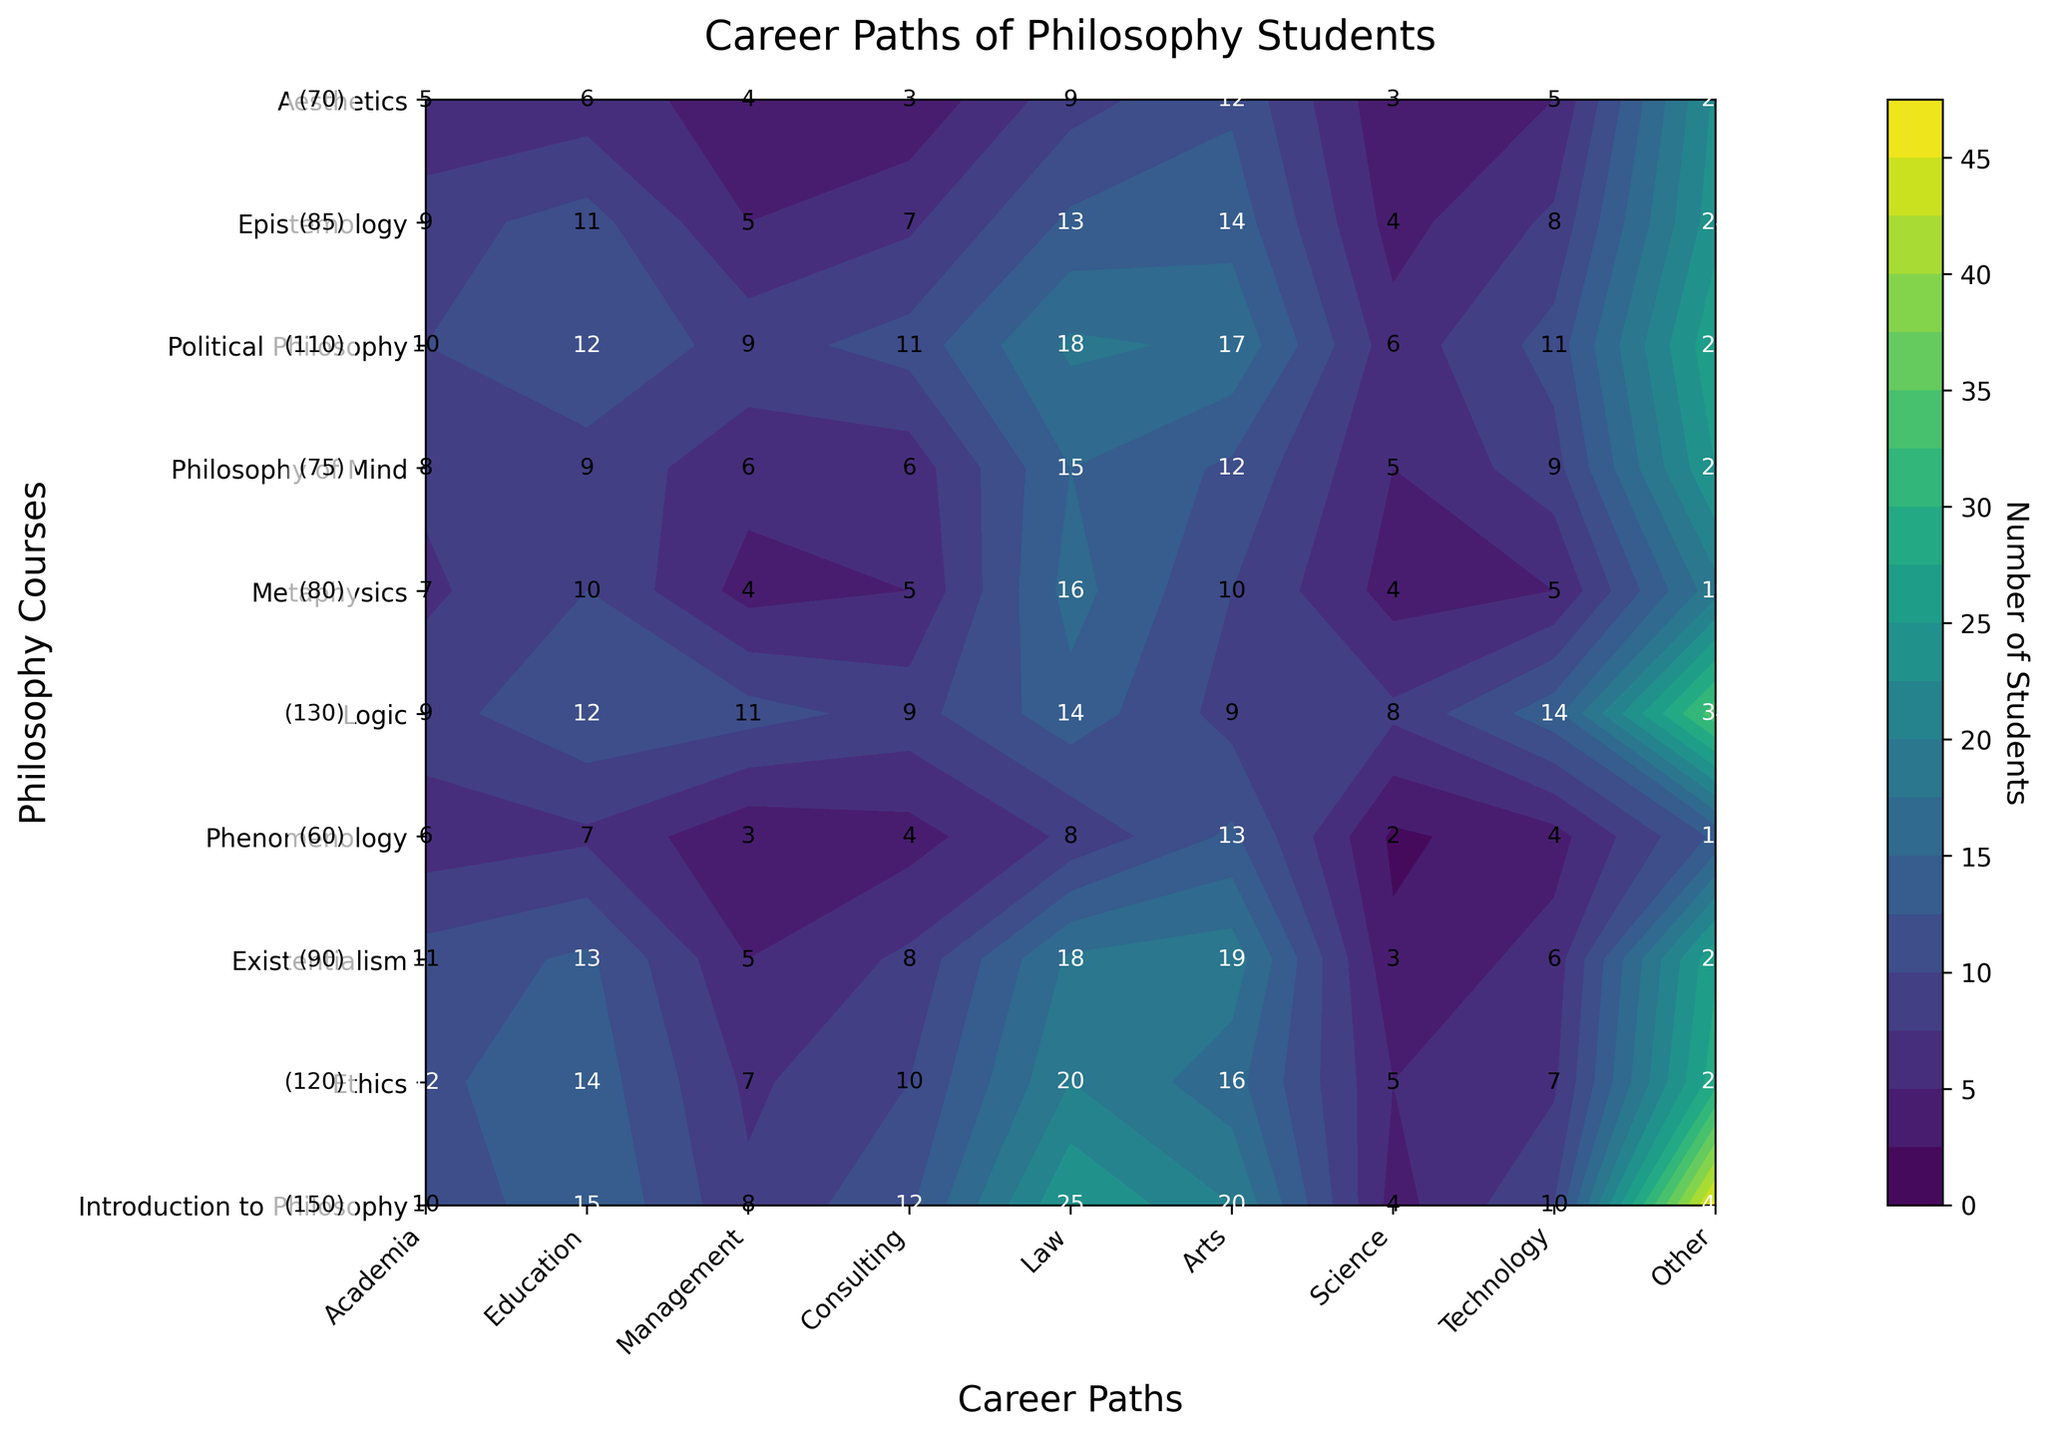What's the title of the plot? The title of the plot is prominently displayed at the top.
Answer: Career Paths of Philosophy Students How many career paths are represented on the x-axis? The number of labels on the x-axis represents the number of career paths. Count them.
Answer: 9 Which philosophy course has the highest enrollment? Look at the text labels on the y-axis representing enrollment numbers. Identify the course with the highest number.
Answer: Introduction to Philosophy What is the number of students who pursued a career in Law after taking the Ethics course? Locate the Ethics course on the y-axis, then find the corresponding value under the Law column on the x-axis.
Answer: 20 Between the Philosophy of Mind and Phenomenology courses, which has more students pursuing a career in Education? Compare the values in the Education column for the Philosophy of Mind and Phenomenology courses.
Answer: Philosophy of Mind Which career path has the highest number of students from the Existentialism course? Find the Existentialism row and identify the highest value in that row; match it to its corresponding career path.
Answer: Law What is the total number of students who pursued careers in Academia from all the courses combined? Sum the values under the Academia column for all courses.
Answer: 87 Is the average number of students pursuing careers in Technology from all courses higher or lower than those pursuing careers in Arts? Calculate the average number of students for Technology and Arts careers across all courses, then compare these averages.
Answer: Lower How many students from the Logic course pursued a career in Consulting? Find the Logic course row and look under the Consulting column to find the corresponding value.
Answer: 9 Which course has the least number of students pursuing careers in Science? Find the smallest value in the Science column and match it to its corresponding course.
Answer: Phenomenology 